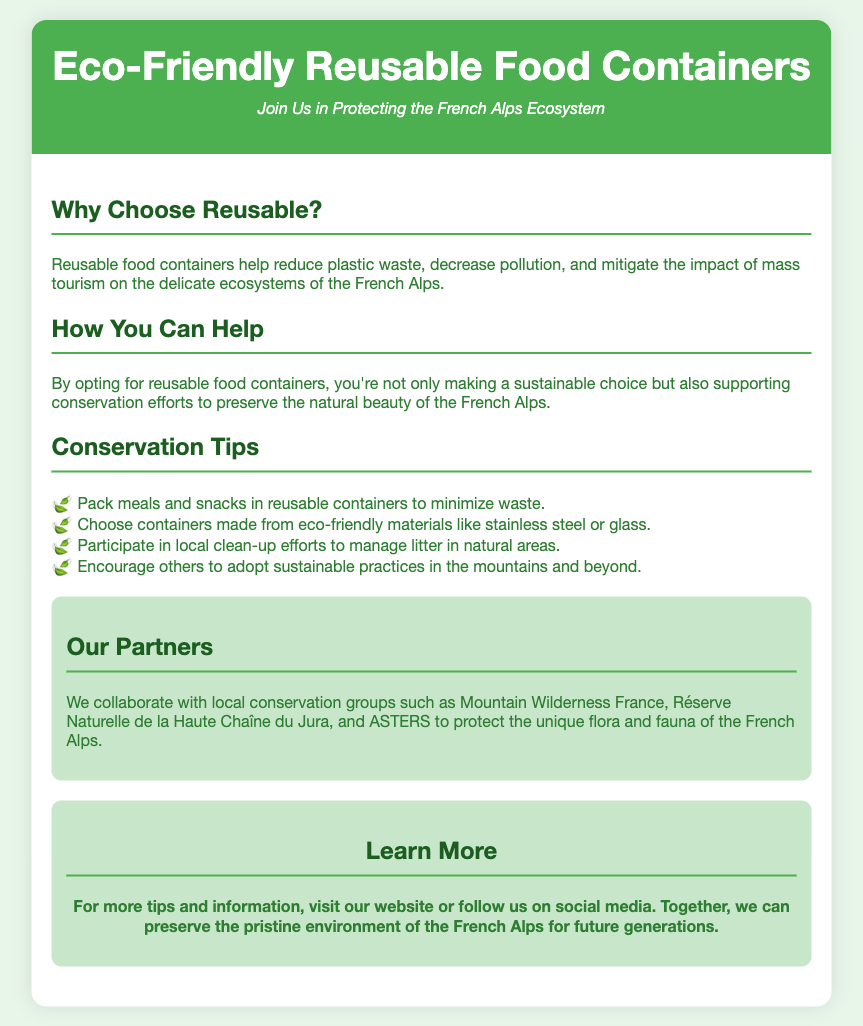What is the main purpose of reusable food containers? The document states that reusable food containers help reduce plastic waste, decrease pollution, and mitigate the impact of mass tourism on the delicate ecosystems of the French Alps.
Answer: Reduce plastic waste What materials should be chosen for containers? The document mentions containers made from eco-friendly materials that include stainless steel or glass.
Answer: Stainless steel or glass What is the collaboration name mentioned in the partners section? The document lists Mountain Wilderness France as one of the partners collaborating to protect the flora and fauna of the French Alps.
Answer: Mountain Wilderness France How many conservation tips are provided? The document lists four conservation tips under the Conservation Tips section.
Answer: Four What type of organizations does the document mention as partners? The document states that they collaborate with local conservation groups to protect the ecosystem.
Answer: Local conservation groups What section follows the "Conservation Tips"? The section immediately following the Conservation Tips section is titled "Our Partners."
Answer: Our Partners 